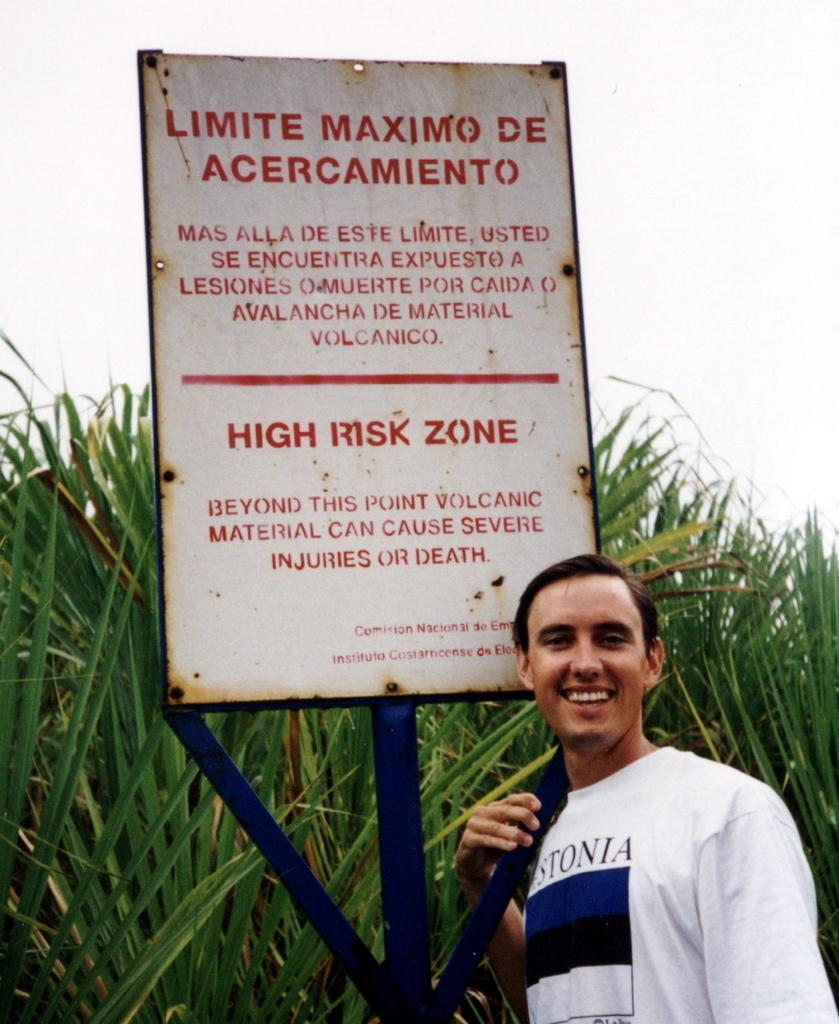<image>
Summarize the visual content of the image. A person stands in front of a sign that says "High risk zone" near a volcano. 